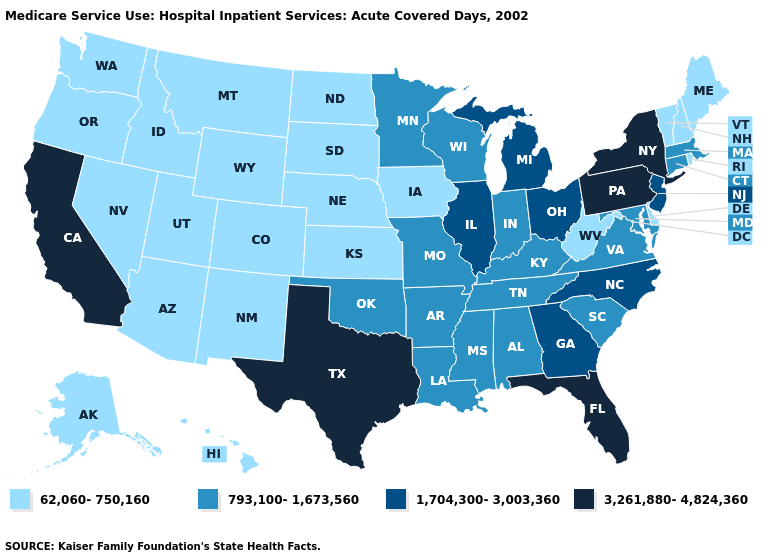Name the states that have a value in the range 3,261,880-4,824,360?
Write a very short answer. California, Florida, New York, Pennsylvania, Texas. Does the map have missing data?
Concise answer only. No. Does North Dakota have the lowest value in the MidWest?
Write a very short answer. Yes. Is the legend a continuous bar?
Write a very short answer. No. Name the states that have a value in the range 1,704,300-3,003,360?
Write a very short answer. Georgia, Illinois, Michigan, New Jersey, North Carolina, Ohio. Does California have the same value as Pennsylvania?
Concise answer only. Yes. Which states hav the highest value in the MidWest?
Quick response, please. Illinois, Michigan, Ohio. Does the first symbol in the legend represent the smallest category?
Give a very brief answer. Yes. Name the states that have a value in the range 62,060-750,160?
Give a very brief answer. Alaska, Arizona, Colorado, Delaware, Hawaii, Idaho, Iowa, Kansas, Maine, Montana, Nebraska, Nevada, New Hampshire, New Mexico, North Dakota, Oregon, Rhode Island, South Dakota, Utah, Vermont, Washington, West Virginia, Wyoming. Does Vermont have the highest value in the USA?
Write a very short answer. No. What is the value of Montana?
Answer briefly. 62,060-750,160. Name the states that have a value in the range 3,261,880-4,824,360?
Concise answer only. California, Florida, New York, Pennsylvania, Texas. Name the states that have a value in the range 3,261,880-4,824,360?
Concise answer only. California, Florida, New York, Pennsylvania, Texas. 